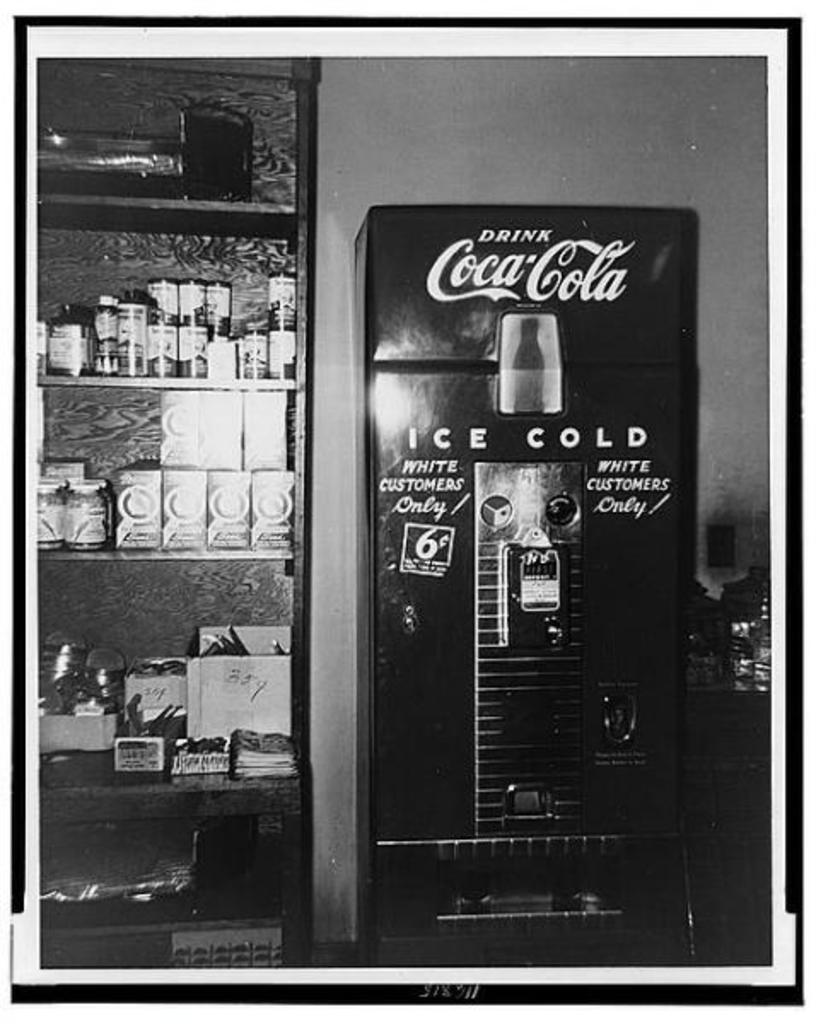Provide a one-sentence caption for the provided image. An old coke vending machine next to a pantry. 